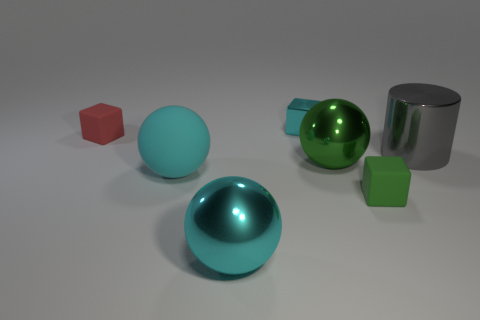Is there any other thing that has the same color as the large matte sphere?
Your answer should be very brief. Yes. Does the small shiny thing have the same color as the big ball left of the cyan metal ball?
Keep it short and to the point. Yes. What number of other things are the same size as the cyan cube?
Your answer should be very brief. 2. What is the size of the ball that is the same color as the big rubber object?
Ensure brevity in your answer.  Large. How many spheres are either big metallic objects or small cyan metallic things?
Give a very brief answer. 2. Is the shape of the cyan object that is in front of the big rubber sphere the same as  the big cyan rubber object?
Give a very brief answer. Yes. Is the number of large rubber balls that are to the right of the large cyan metallic ball greater than the number of small green rubber blocks?
Offer a terse response. No. What is the color of the other shiny sphere that is the same size as the green sphere?
Ensure brevity in your answer.  Cyan. What number of things are either large spheres in front of the tiny green cube or yellow metal things?
Offer a very short reply. 1. There is a large rubber thing that is the same color as the metallic cube; what shape is it?
Make the answer very short. Sphere. 